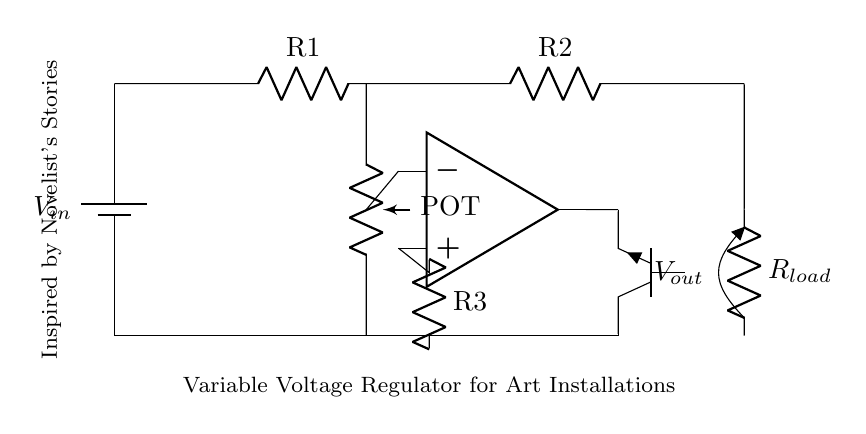What type of voltage regulator is used in this circuit? The circuit uses a variable voltage regulator, which allows the output voltage to be adjusted. This can be inferred from the presence of the potentiometer labeled as "POT" that is connected in a way that alters the feedback to the op-amp.
Answer: Variable voltage regulator What is the function of the operational amplifier in this circuit? The operational amplifier acts as a comparator by receiving voltage input from the potentiometer and adjusting the output to control the transistor. This is crucial for maintaining a stable output voltage based on the variable resistance from the potentiometer.
Answer: Comparator How many resistors are present in the circuit? There are three resistors (R1, R2, and R3) included in the circuit diagram, which are used for different purposes such as voltage division and feedback control for the op-amp.
Answer: Three What does the output voltage depend on in this variable voltage regulator? The output voltage depends on the setting of the potentiometer. As the potentiometer is adjusted, it changes the feedback to the operational amplifier, which ultimately alters the output voltage delivered to the load.
Answer: Potentiometer setting What is the type of transistor used for the output in this circuit? A NPN transistor is used as the output component, which is indicated by the label "npn" next to the transistor symbol. This type of transistor is commonly used for switching and amplification purposes in such circuits.
Answer: NPN What is the purpose of the load resistor (R_load) in this circuit? The load resistor (R_load) is used to represent the connected electronic devices, and it determines the amount of current drawn from the power source, facilitating the demonstration of how the voltage regulator will perform under load conditions.
Answer: Represents load current 